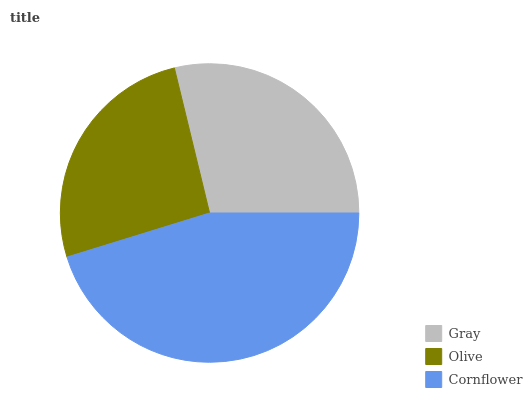Is Olive the minimum?
Answer yes or no. Yes. Is Cornflower the maximum?
Answer yes or no. Yes. Is Cornflower the minimum?
Answer yes or no. No. Is Olive the maximum?
Answer yes or no. No. Is Cornflower greater than Olive?
Answer yes or no. Yes. Is Olive less than Cornflower?
Answer yes or no. Yes. Is Olive greater than Cornflower?
Answer yes or no. No. Is Cornflower less than Olive?
Answer yes or no. No. Is Gray the high median?
Answer yes or no. Yes. Is Gray the low median?
Answer yes or no. Yes. Is Cornflower the high median?
Answer yes or no. No. Is Cornflower the low median?
Answer yes or no. No. 